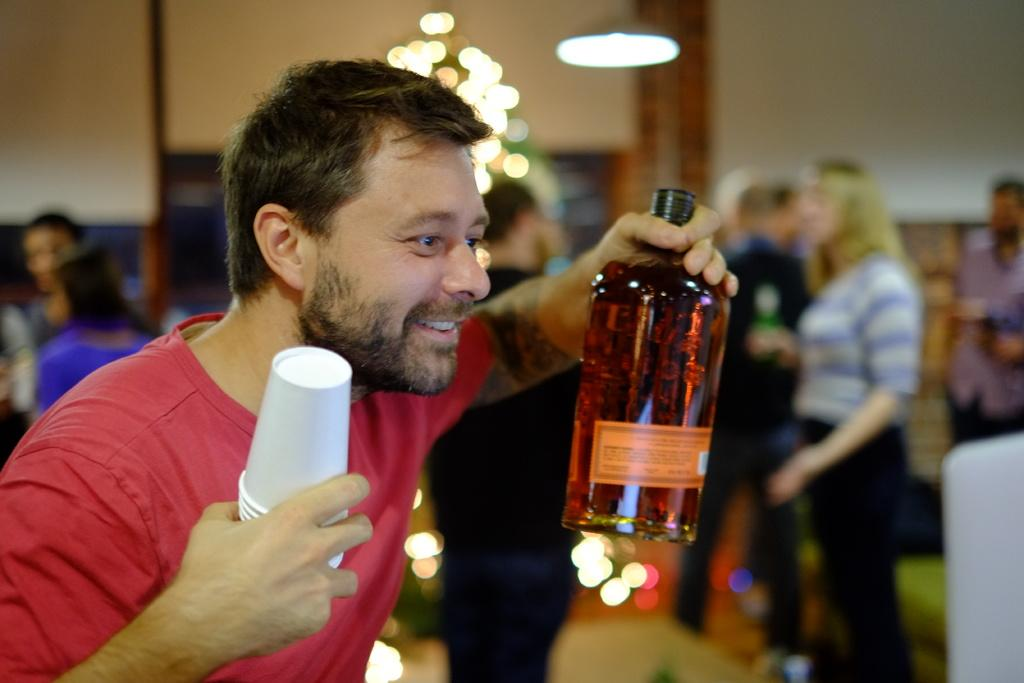Who is present in the image? There is a man in the image. What is the man holding in his hands? The man is holding a bottle and paper cups. Can you describe the background of the image? There are people standing in the background of the image. What type of jewel can be seen on the man's neck in the image? There is no jewel visible on the man's neck in the image. How many men are present in the cemetery in the image? There is no cemetery present in the image, and therefore no men can be found there. 